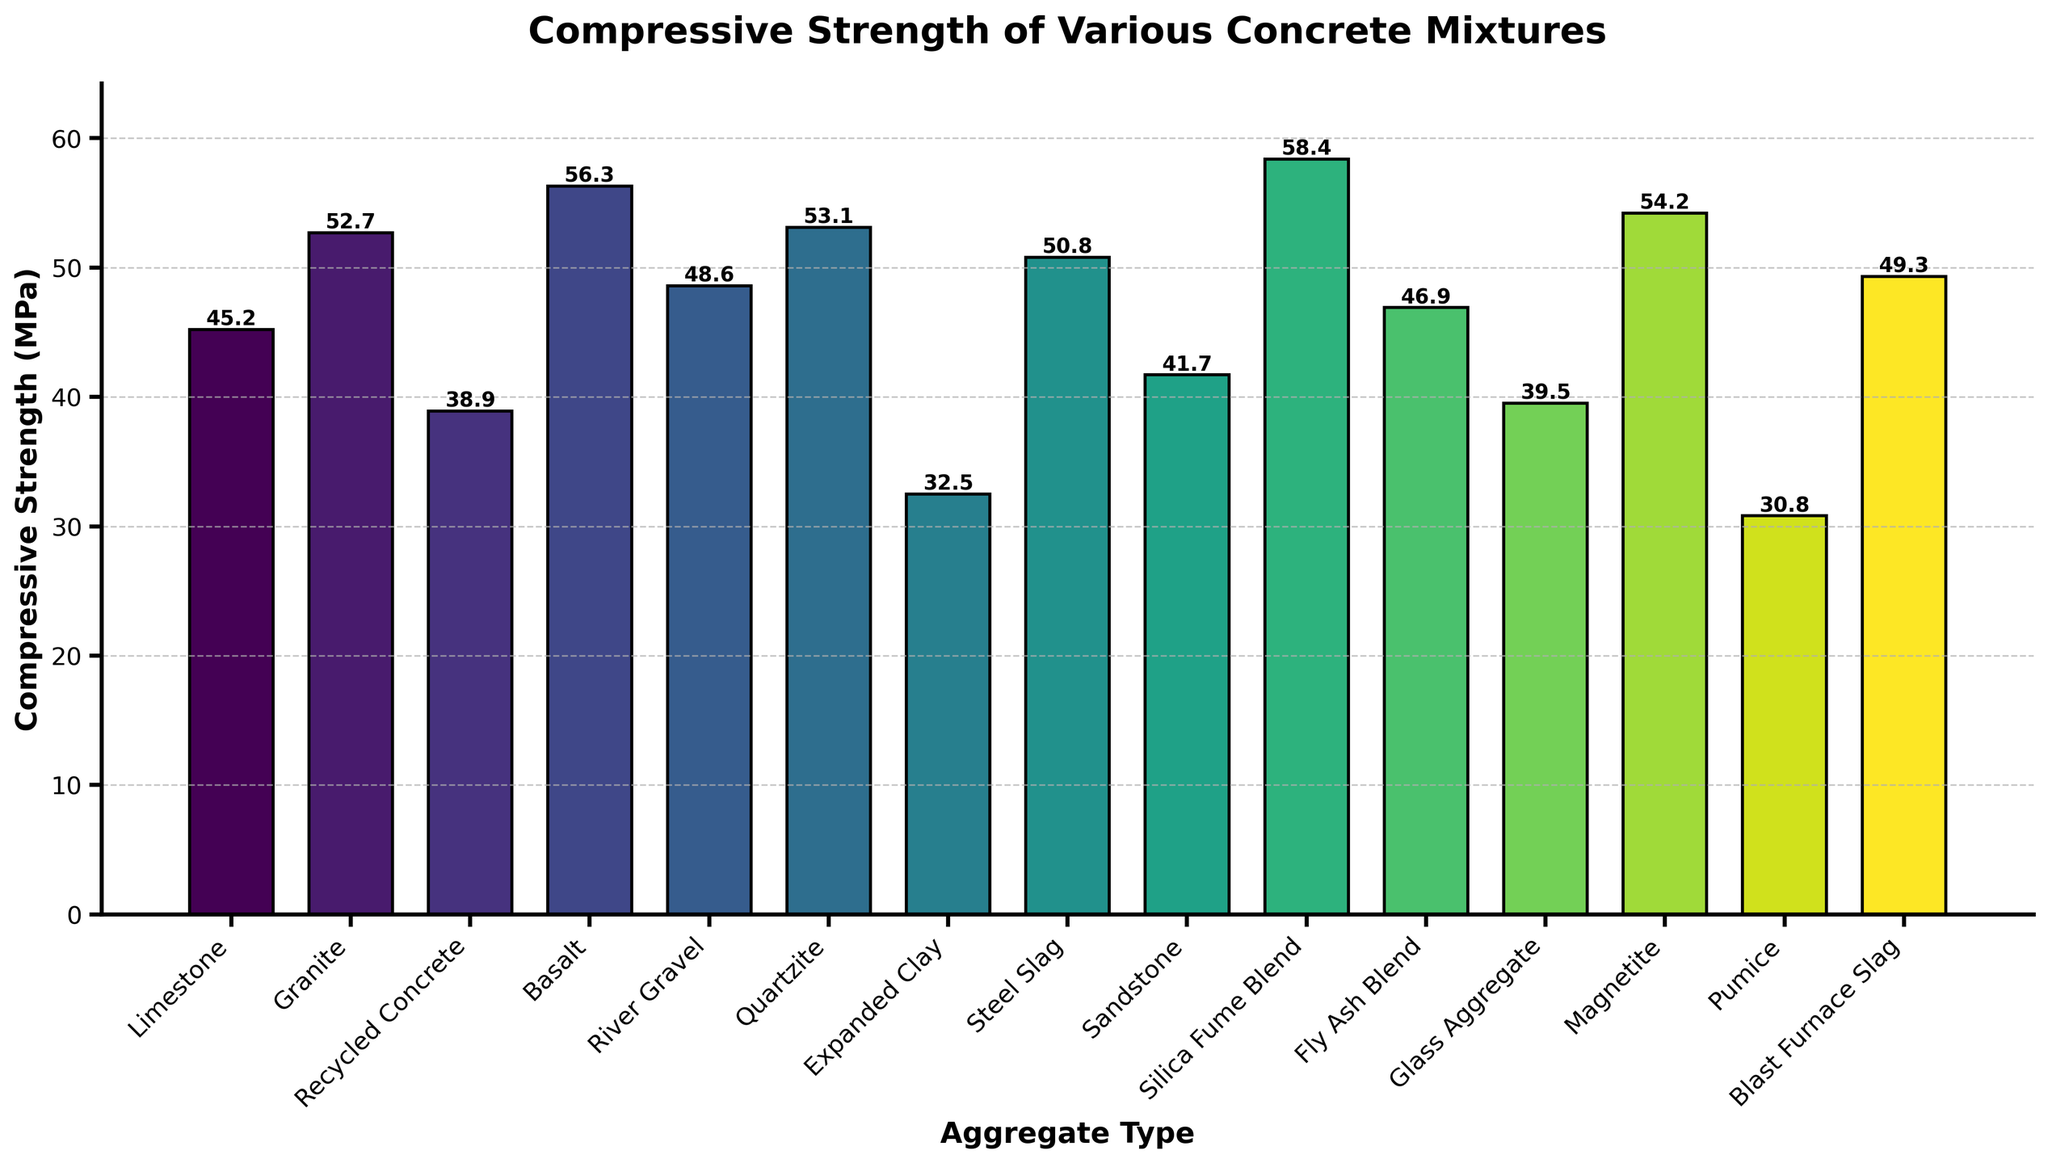Which aggregate type provides the highest compressive strength? By observing the bar chart, we can see that the tallest bar represents the compressive strength of each aggregate type. The tallest bar is for Silica Fume Blend, indicating it has the highest compressive strength.
Answer: Silica Fume Blend What is the compressive strength difference between Magnetite and Recycled Concrete? The compressive strength of Magnetite is 54.2 MPa and Recycled Concrete is 38.9 MPa. To find the difference, subtract the smaller value from the larger: 54.2 - 38.9 = 15.3 MPa.
Answer: 15.3 MPa Which aggregate types have a compressive strength above 50 MPa? By inspecting bars with heights above the 50 MPa mark, we find Granite (52.7 MPa), Basalt (56.3 MPa), Quartzite (53.1 MPa), Silica Fume Blend (58.4 MPa), Magnetite (54.2 MPa), and Steel Slag (50.8 MPa).
Answer: Granite, Basalt, Quartzite, Silica Fume Blend, Magnetite, Steel Slag What is the median compressive strength of the listed aggregate types? To find the median, list all compressive strength values in ascending order: (30.8, 32.5, 38.9, 39.5, 41.7, 45.2, 46.9, 48.6, 49.3, 50.8, 52.7, 53.1, 54.2, 56.3, 58.4). The middle value (8th in the list) is the median: 48.6 MPa.
Answer: 48.6 MPa How does the compressive strength of Quartzite compare to that of Limestone? The compressive strength of Quartzite is 53.1 MPa, and that of Limestone is 45.2 MPa. Since 53.1 is greater than 45.2, Quartzite has a higher compressive strength than Limestone.
Answer: Quartzite is higher Which aggregate type has the lowest compressive strength? The shortest bar in the plot indicates the lowest compressive strength. The bar corresponding to Pumice is the shortest, making it the aggregate type with the lowest compressive strength.
Answer: Pumice What is the total compressive strength of all aggregates combined? Sum all the compressive strength values: 45.2 + 52.7 + 38.9 + 56.3 + 48.6 + 53.1 + 32.5 + 50.8 + 41.7 + 58.4 + 46.9 + 39.5 + 54.2 + 30.8 + 49.3 = 698.9 MPa.
Answer: 698.9 MPa Compare the compressive strength of Expanded Clay with that of Blast Furnace Slag. Which one is higher and by how much? The compressive strength of Expanded Clay is 32.5 MPa and Blast Furnace Slag is 49.3 MPa. Since 49.3 is greater than 32.5, Blast Furnace Slag is higher by 49.3 - 32.5 = 16.8 MPa.
Answer: Blast Furnace Slag by 16.8 MPa 